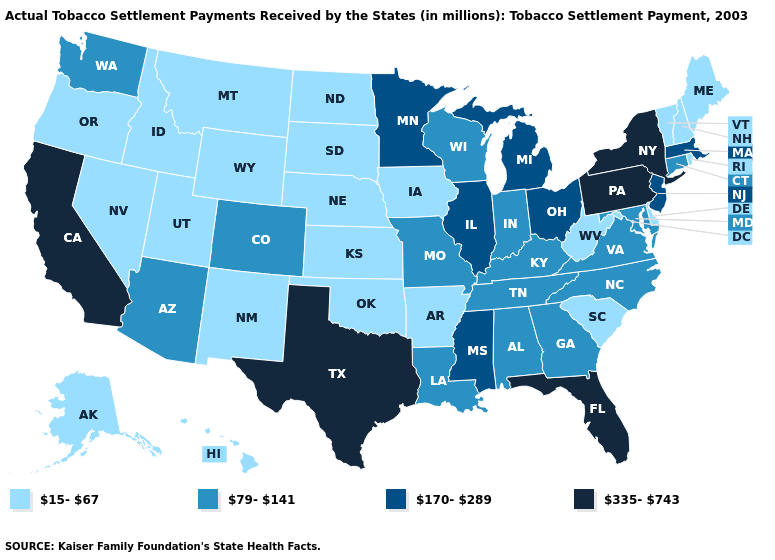Name the states that have a value in the range 79-141?
Short answer required. Alabama, Arizona, Colorado, Connecticut, Georgia, Indiana, Kentucky, Louisiana, Maryland, Missouri, North Carolina, Tennessee, Virginia, Washington, Wisconsin. Does the first symbol in the legend represent the smallest category?
Write a very short answer. Yes. What is the highest value in the West ?
Answer briefly. 335-743. What is the value of Louisiana?
Quick response, please. 79-141. Name the states that have a value in the range 15-67?
Concise answer only. Alaska, Arkansas, Delaware, Hawaii, Idaho, Iowa, Kansas, Maine, Montana, Nebraska, Nevada, New Hampshire, New Mexico, North Dakota, Oklahoma, Oregon, Rhode Island, South Carolina, South Dakota, Utah, Vermont, West Virginia, Wyoming. Is the legend a continuous bar?
Concise answer only. No. Does Kansas have the highest value in the USA?
Quick response, please. No. What is the value of Pennsylvania?
Short answer required. 335-743. What is the lowest value in states that border New Hampshire?
Answer briefly. 15-67. Among the states that border Oregon , which have the highest value?
Give a very brief answer. California. Name the states that have a value in the range 79-141?
Answer briefly. Alabama, Arizona, Colorado, Connecticut, Georgia, Indiana, Kentucky, Louisiana, Maryland, Missouri, North Carolina, Tennessee, Virginia, Washington, Wisconsin. What is the value of Hawaii?
Answer briefly. 15-67. Name the states that have a value in the range 15-67?
Keep it brief. Alaska, Arkansas, Delaware, Hawaii, Idaho, Iowa, Kansas, Maine, Montana, Nebraska, Nevada, New Hampshire, New Mexico, North Dakota, Oklahoma, Oregon, Rhode Island, South Carolina, South Dakota, Utah, Vermont, West Virginia, Wyoming. 